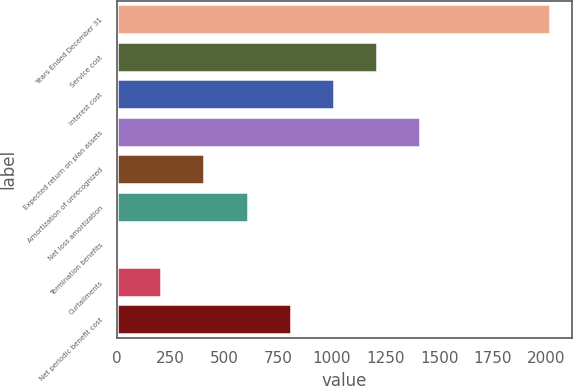Convert chart to OTSL. <chart><loc_0><loc_0><loc_500><loc_500><bar_chart><fcel>Years Ended December 31<fcel>Service cost<fcel>Interest cost<fcel>Expected return on plan assets<fcel>Amortization of unrecognized<fcel>Net loss amortization<fcel>Termination benefits<fcel>Curtailments<fcel>Net periodic benefit cost<nl><fcel>2017<fcel>1211.8<fcel>1010.5<fcel>1413.1<fcel>406.6<fcel>607.9<fcel>4<fcel>205.3<fcel>809.2<nl></chart> 